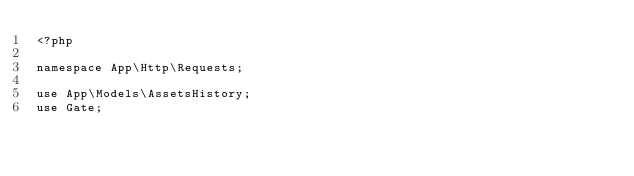Convert code to text. <code><loc_0><loc_0><loc_500><loc_500><_PHP_><?php

namespace App\Http\Requests;

use App\Models\AssetsHistory;
use Gate;</code> 